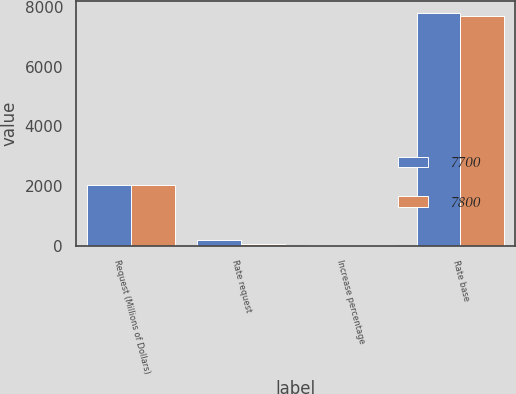Convert chart. <chart><loc_0><loc_0><loc_500><loc_500><stacked_bar_chart><ecel><fcel>Request (Millions of Dollars)<fcel>Rate request<fcel>Increase percentage<fcel>Rate base<nl><fcel>7700<fcel>2016<fcel>194.6<fcel>6.4<fcel>7800<nl><fcel>7800<fcel>2017<fcel>52.1<fcel>1.7<fcel>7700<nl></chart> 